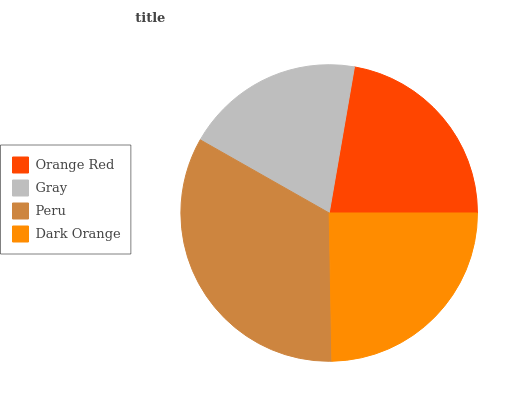Is Gray the minimum?
Answer yes or no. Yes. Is Peru the maximum?
Answer yes or no. Yes. Is Peru the minimum?
Answer yes or no. No. Is Gray the maximum?
Answer yes or no. No. Is Peru greater than Gray?
Answer yes or no. Yes. Is Gray less than Peru?
Answer yes or no. Yes. Is Gray greater than Peru?
Answer yes or no. No. Is Peru less than Gray?
Answer yes or no. No. Is Dark Orange the high median?
Answer yes or no. Yes. Is Orange Red the low median?
Answer yes or no. Yes. Is Orange Red the high median?
Answer yes or no. No. Is Peru the low median?
Answer yes or no. No. 